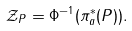Convert formula to latex. <formula><loc_0><loc_0><loc_500><loc_500>\mathcal { Z } _ { P } = \Phi ^ { - 1 } ( \pi _ { a } ^ { * } ( P ) ) .</formula> 